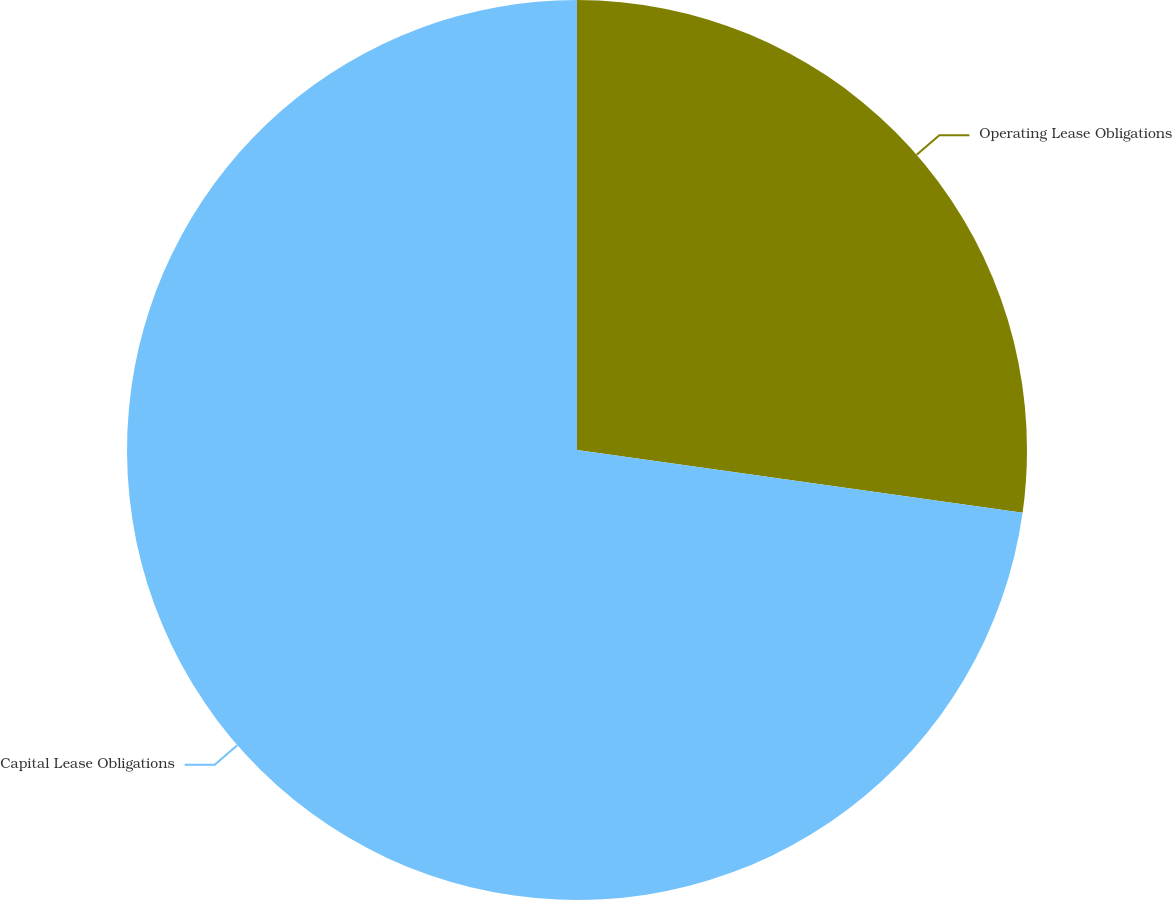<chart> <loc_0><loc_0><loc_500><loc_500><pie_chart><fcel>Operating Lease Obligations<fcel>Capital Lease Obligations<nl><fcel>27.23%<fcel>72.77%<nl></chart> 